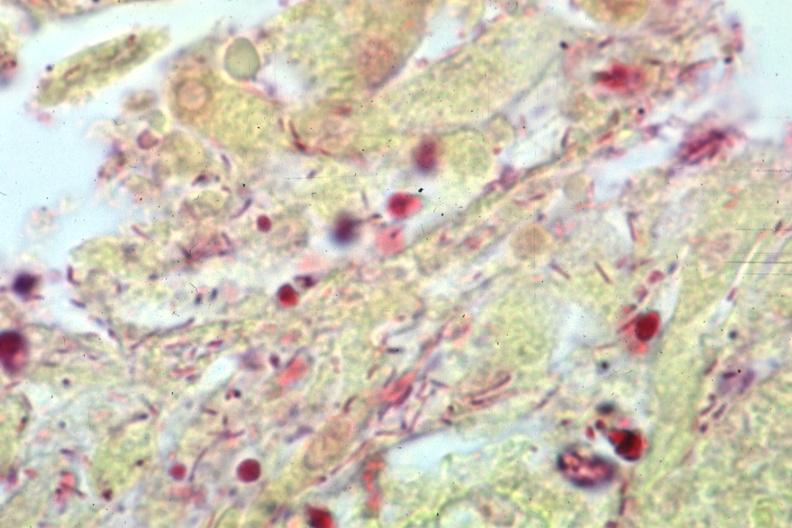does gram stain gram negative bacteria?
Answer the question using a single word or phrase. Yes 